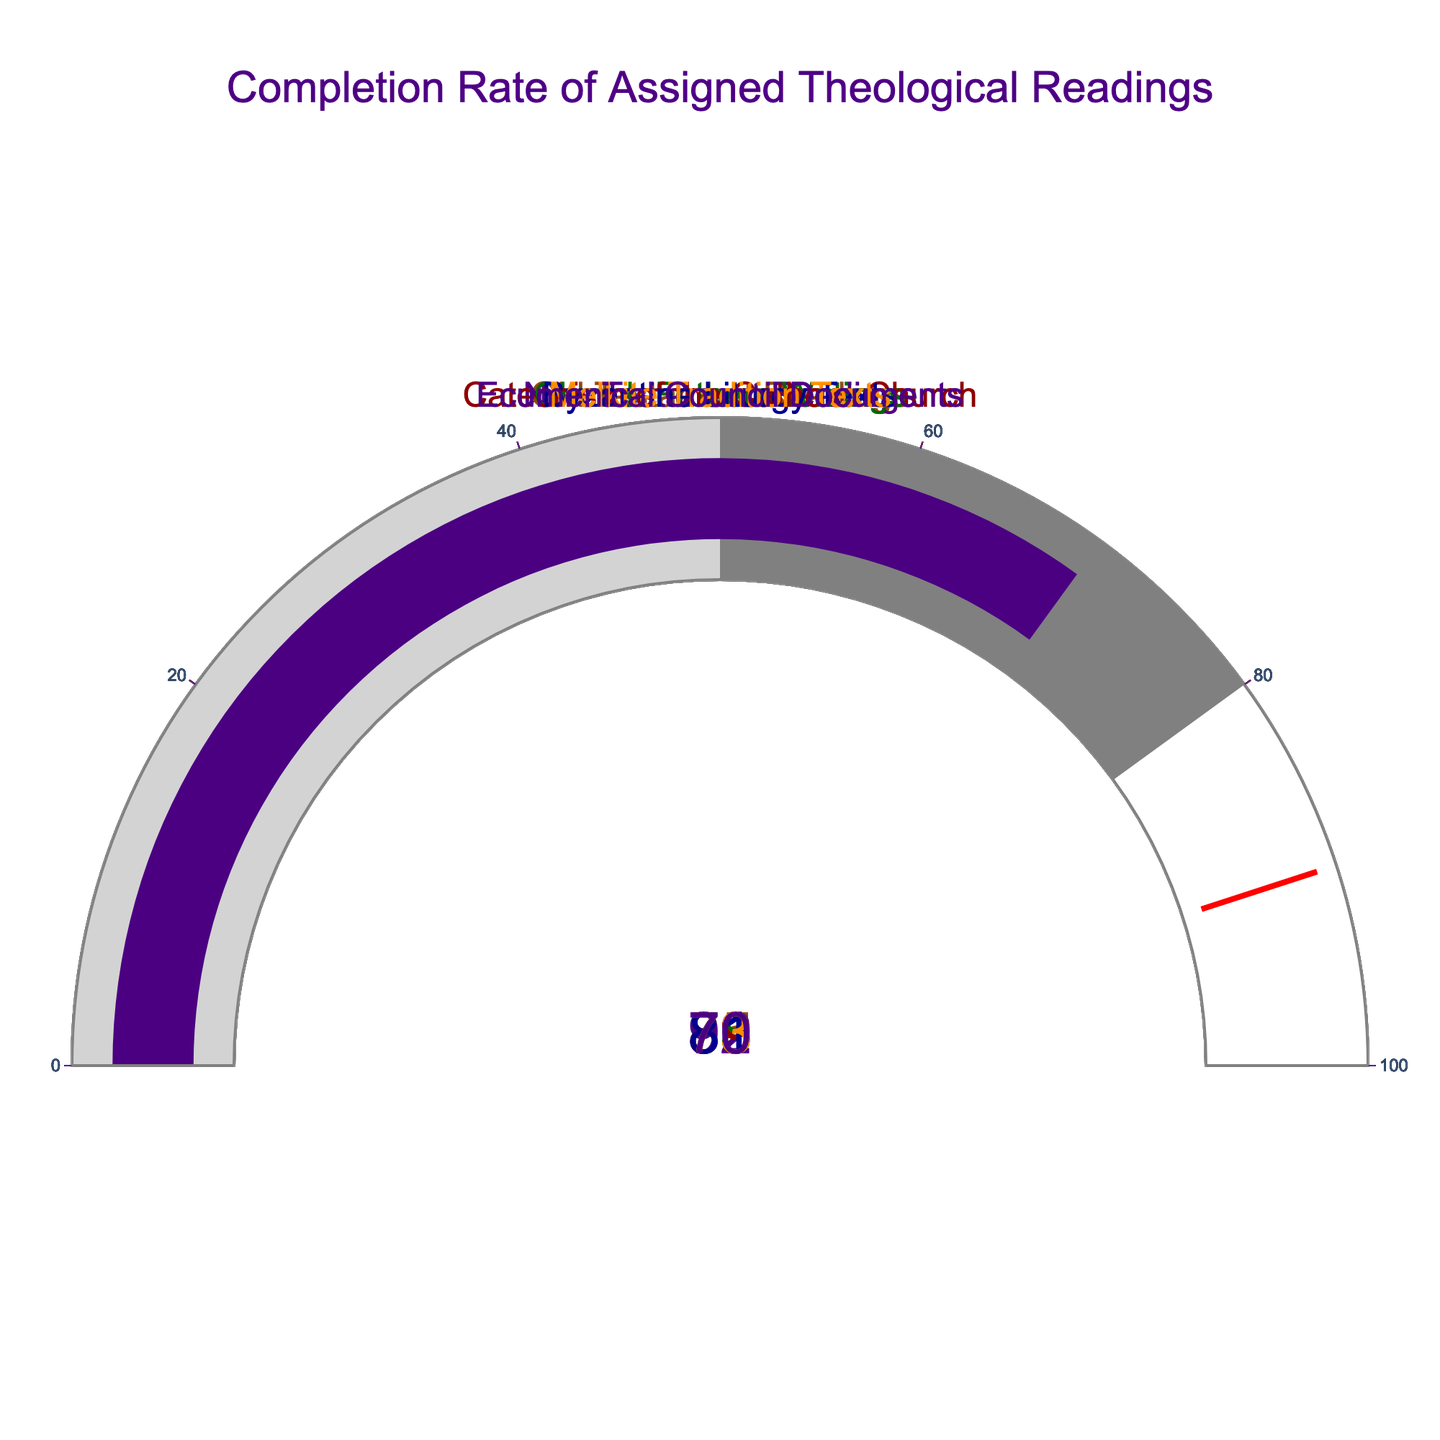What's the highest completion rate shown in the plot? By examining each gauge, we see that the New Testament Readings has the highest completion rate at 92%.
Answer: 92% Which assigned reading has the lowest completion rate? Looking at the gauges, the Ecumenical Council Documents has the lowest completion rate with a value of 70.
Answer: Ecumenical Council Documents What is the difference between the highest and lowest completion rates? The highest completion rate is 92% (New Testament Readings), and the lowest is 70% (Ecumenical Council Documents). The difference is 92 - 70.
Answer: 22 What is the average completion rate of all assigned readings? Adding up all the completion rates (85 + 92 + 78 + 89 + 81 + 73 + 70) and dividing by the number of readings (7), we get 568 / 7.
Answer: 81.14 Which readings have a completion rate above 80%? The readings with completion rates above 80% are Old Testament Readings (85), New Testament Readings (92), Catechism of the Catholic Church (89), and Byzantine Liturgy Texts (81).
Answer: Old Testament Readings, New Testament Readings, Catechism of the Catholic Church, Byzantine Liturgy Texts Is the completion rate for Byzantine Liturgy Texts above the threshold of 90%? The threshold marked on the gauges is 90%, but the completion rate for Byzantine Liturgy Texts is 81%, which is below this threshold.
Answer: No How many readings have a completion rate below 80%? By counting the gauges with values below 80%, we find three: Church Fathers Writings (78), Melkite Tradition Texts (73), and Ecumenical Council Documents (70).
Answer: 3 Which readings are closest in completion rate to the threshold of 90%? The closest readings to the threshold of 90% (but lower) are Catechism of the Catholic Church with an 89% completion rate, and Old Testament Readings with an 85% completion rate.
Answer: Catechism of the Catholic Church, Old Testament Readings Is the completion rate for Melkite Tradition Texts higher or lower than that for Church Fathers Writings? Comparing the two gauges, Melkite Tradition Texts has a completion rate of 73, whereas Church Fathers Writings has a completion rate of 78.
Answer: Lower 